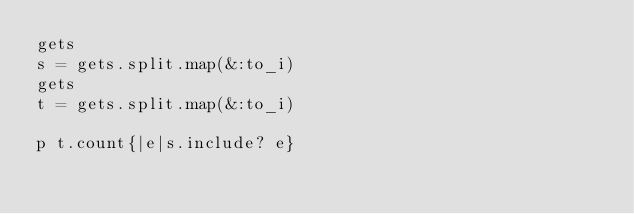<code> <loc_0><loc_0><loc_500><loc_500><_Ruby_>gets
s = gets.split.map(&:to_i)
gets
t = gets.split.map(&:to_i)

p t.count{|e|s.include? e}

</code> 